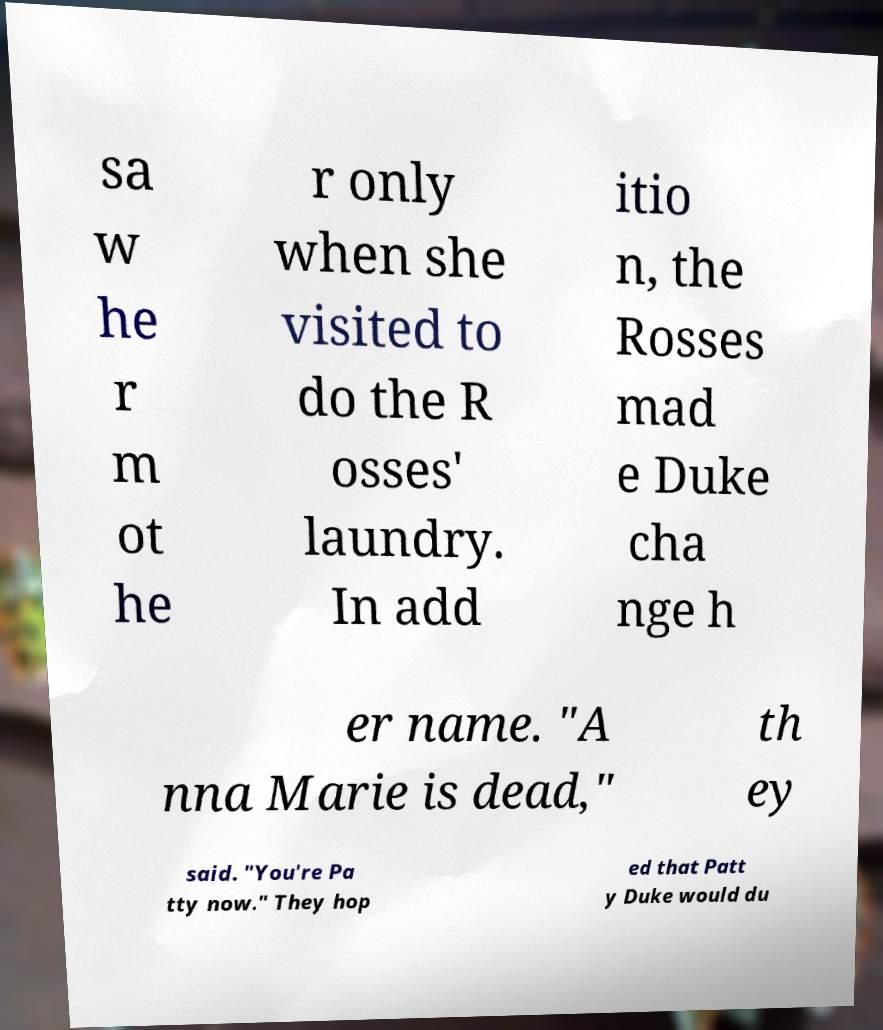Please identify and transcribe the text found in this image. sa w he r m ot he r only when she visited to do the R osses' laundry. In add itio n, the Rosses mad e Duke cha nge h er name. "A nna Marie is dead," th ey said. "You're Pa tty now." They hop ed that Patt y Duke would du 